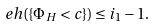Convert formula to latex. <formula><loc_0><loc_0><loc_500><loc_500>\ e h ( \{ \Phi _ { H } < c \} ) \leq i _ { 1 } - 1 .</formula> 